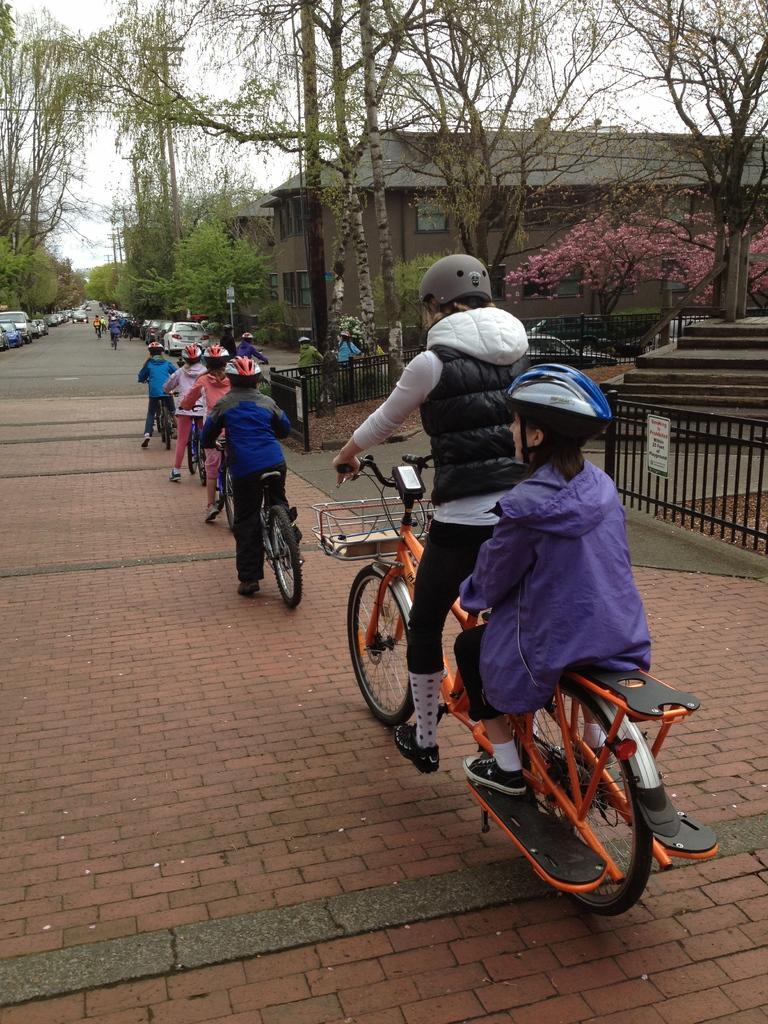Could you give a brief overview of what you see in this image? There are many people wearing helmets are riding bikes on the road. On the sides of the road there are trees, vehicles, railings. Also there are buildings. In the background there is sky. 